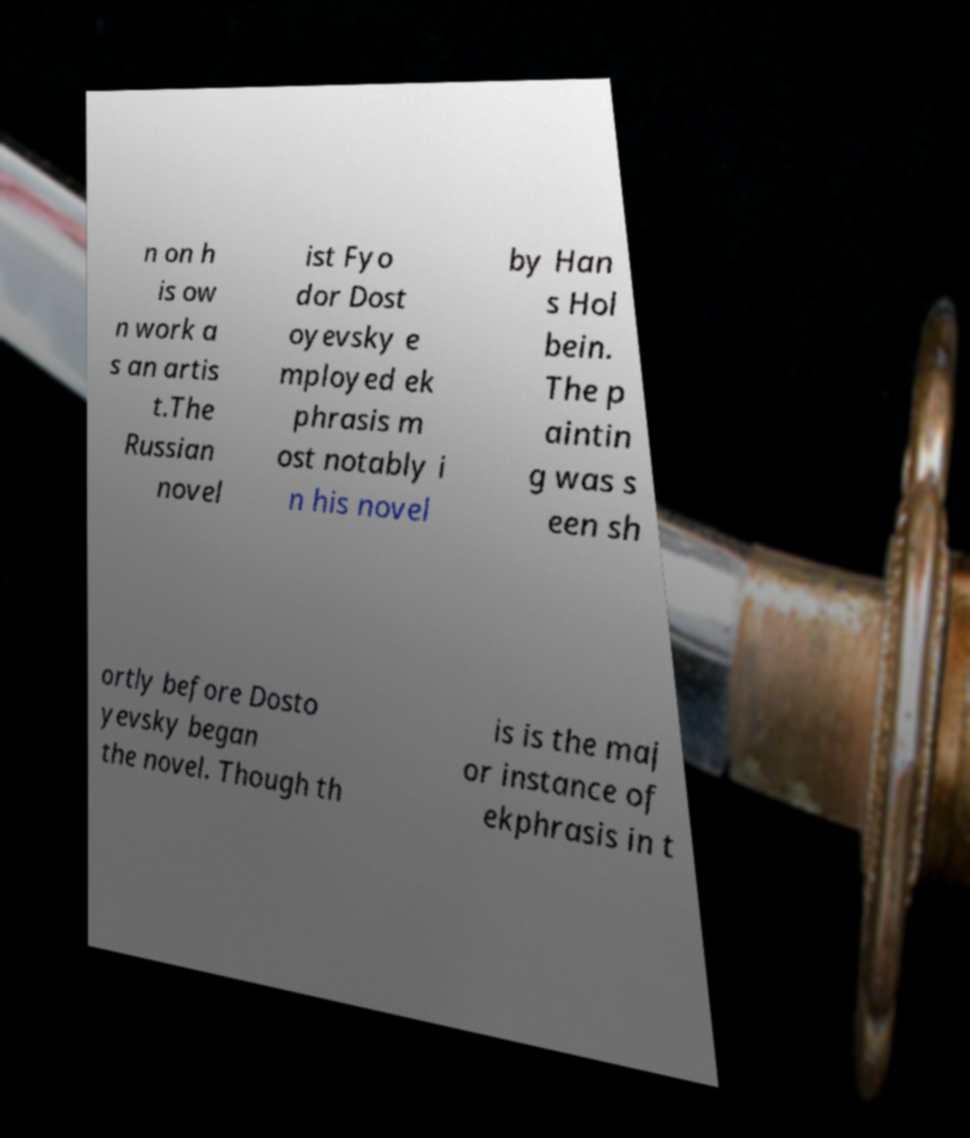Can you read and provide the text displayed in the image?This photo seems to have some interesting text. Can you extract and type it out for me? n on h is ow n work a s an artis t.The Russian novel ist Fyo dor Dost oyevsky e mployed ek phrasis m ost notably i n his novel by Han s Hol bein. The p aintin g was s een sh ortly before Dosto yevsky began the novel. Though th is is the maj or instance of ekphrasis in t 